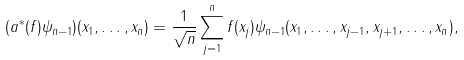<formula> <loc_0><loc_0><loc_500><loc_500>( a ^ { \ast } ( f ) \psi _ { n - 1 } ) ( x _ { 1 } , \dots , x _ { n } ) = \frac { 1 } { \sqrt { n } } \sum _ { j = 1 } ^ { n } f ( x _ { j } ) \psi _ { n - 1 } ( x _ { 1 } , \dots , x _ { j - 1 } , x _ { j + 1 } , \dots , x _ { n } ) ,</formula> 